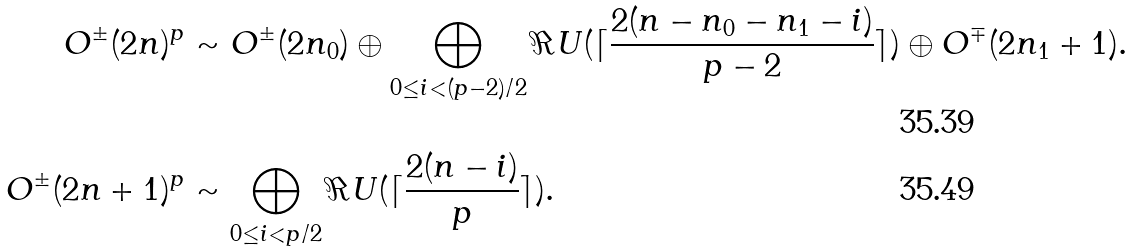<formula> <loc_0><loc_0><loc_500><loc_500>O ^ { \pm } ( 2 n ) ^ { p } & \sim O ^ { \pm } ( 2 n _ { 0 } ) \oplus \bigoplus _ { 0 \leq i < ( p - 2 ) / 2 } \Re U ( \lceil \frac { 2 ( n - n _ { 0 } - n _ { 1 } - i ) } { p - 2 } \rceil ) \oplus O ^ { \mp } ( 2 n _ { 1 } + 1 ) . \\ O ^ { \pm } ( 2 n + 1 ) ^ { p } & \sim \bigoplus _ { 0 \leq i < p / 2 } \Re U ( \lceil \frac { 2 ( n - i ) } { p } \rceil ) .</formula> 